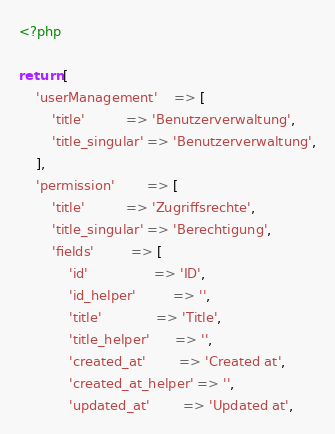Convert code to text. <code><loc_0><loc_0><loc_500><loc_500><_PHP_><?php

return [
    'userManagement'    => [
        'title'          => 'Benutzerverwaltung',
        'title_singular' => 'Benutzerverwaltung',
    ],
    'permission'        => [
        'title'          => 'Zugriffsrechte',
        'title_singular' => 'Berechtigung',
        'fields'         => [
            'id'                => 'ID',
            'id_helper'         => '',
            'title'             => 'Title',
            'title_helper'      => '',
            'created_at'        => 'Created at',
            'created_at_helper' => '',
            'updated_at'        => 'Updated at',</code> 